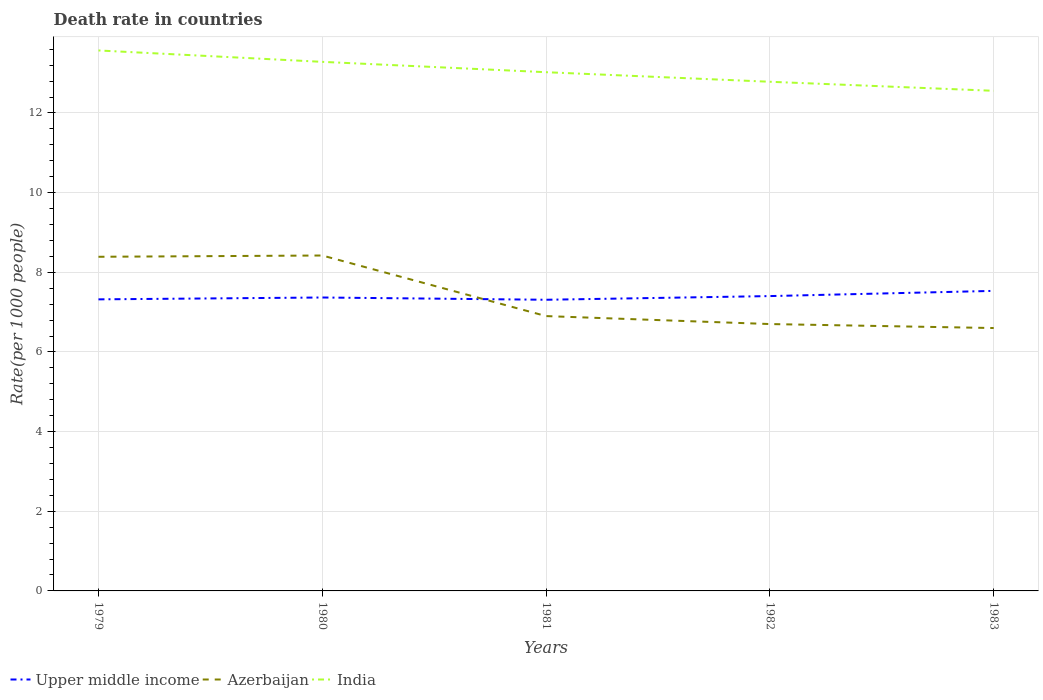Is the number of lines equal to the number of legend labels?
Provide a succinct answer. Yes. Across all years, what is the maximum death rate in Upper middle income?
Keep it short and to the point. 7.31. In which year was the death rate in Upper middle income maximum?
Give a very brief answer. 1981. What is the total death rate in Azerbaijan in the graph?
Your answer should be compact. 1.52. What is the difference between the highest and the second highest death rate in Azerbaijan?
Keep it short and to the point. 1.82. What is the difference between the highest and the lowest death rate in India?
Make the answer very short. 2. Are the values on the major ticks of Y-axis written in scientific E-notation?
Provide a succinct answer. No. Does the graph contain any zero values?
Keep it short and to the point. No. Where does the legend appear in the graph?
Provide a short and direct response. Bottom left. What is the title of the graph?
Your answer should be compact. Death rate in countries. What is the label or title of the Y-axis?
Your response must be concise. Rate(per 1000 people). What is the Rate(per 1000 people) of Upper middle income in 1979?
Offer a terse response. 7.32. What is the Rate(per 1000 people) of Azerbaijan in 1979?
Give a very brief answer. 8.39. What is the Rate(per 1000 people) of India in 1979?
Your answer should be compact. 13.57. What is the Rate(per 1000 people) of Upper middle income in 1980?
Provide a succinct answer. 7.37. What is the Rate(per 1000 people) in Azerbaijan in 1980?
Ensure brevity in your answer.  8.42. What is the Rate(per 1000 people) of India in 1980?
Ensure brevity in your answer.  13.28. What is the Rate(per 1000 people) of Upper middle income in 1981?
Provide a short and direct response. 7.31. What is the Rate(per 1000 people) of India in 1981?
Make the answer very short. 13.02. What is the Rate(per 1000 people) in Upper middle income in 1982?
Provide a short and direct response. 7.4. What is the Rate(per 1000 people) of India in 1982?
Ensure brevity in your answer.  12.78. What is the Rate(per 1000 people) in Upper middle income in 1983?
Your answer should be compact. 7.53. What is the Rate(per 1000 people) in India in 1983?
Provide a short and direct response. 12.56. Across all years, what is the maximum Rate(per 1000 people) of Upper middle income?
Provide a succinct answer. 7.53. Across all years, what is the maximum Rate(per 1000 people) of Azerbaijan?
Provide a short and direct response. 8.42. Across all years, what is the maximum Rate(per 1000 people) of India?
Your answer should be compact. 13.57. Across all years, what is the minimum Rate(per 1000 people) in Upper middle income?
Give a very brief answer. 7.31. Across all years, what is the minimum Rate(per 1000 people) in Azerbaijan?
Your answer should be very brief. 6.6. Across all years, what is the minimum Rate(per 1000 people) of India?
Give a very brief answer. 12.56. What is the total Rate(per 1000 people) in Upper middle income in the graph?
Your response must be concise. 36.93. What is the total Rate(per 1000 people) of Azerbaijan in the graph?
Keep it short and to the point. 37.01. What is the total Rate(per 1000 people) in India in the graph?
Your response must be concise. 65.21. What is the difference between the Rate(per 1000 people) in Upper middle income in 1979 and that in 1980?
Your answer should be very brief. -0.05. What is the difference between the Rate(per 1000 people) of Azerbaijan in 1979 and that in 1980?
Your response must be concise. -0.03. What is the difference between the Rate(per 1000 people) of India in 1979 and that in 1980?
Provide a short and direct response. 0.29. What is the difference between the Rate(per 1000 people) in Upper middle income in 1979 and that in 1981?
Ensure brevity in your answer.  0.01. What is the difference between the Rate(per 1000 people) in Azerbaijan in 1979 and that in 1981?
Give a very brief answer. 1.49. What is the difference between the Rate(per 1000 people) of India in 1979 and that in 1981?
Your answer should be very brief. 0.55. What is the difference between the Rate(per 1000 people) of Upper middle income in 1979 and that in 1982?
Your response must be concise. -0.08. What is the difference between the Rate(per 1000 people) of Azerbaijan in 1979 and that in 1982?
Provide a succinct answer. 1.69. What is the difference between the Rate(per 1000 people) in India in 1979 and that in 1982?
Keep it short and to the point. 0.79. What is the difference between the Rate(per 1000 people) in Upper middle income in 1979 and that in 1983?
Make the answer very short. -0.21. What is the difference between the Rate(per 1000 people) in Azerbaijan in 1979 and that in 1983?
Offer a terse response. 1.79. What is the difference between the Rate(per 1000 people) in Upper middle income in 1980 and that in 1981?
Keep it short and to the point. 0.06. What is the difference between the Rate(per 1000 people) in Azerbaijan in 1980 and that in 1981?
Provide a short and direct response. 1.52. What is the difference between the Rate(per 1000 people) of India in 1980 and that in 1981?
Offer a terse response. 0.26. What is the difference between the Rate(per 1000 people) of Upper middle income in 1980 and that in 1982?
Offer a terse response. -0.04. What is the difference between the Rate(per 1000 people) in Azerbaijan in 1980 and that in 1982?
Your answer should be compact. 1.72. What is the difference between the Rate(per 1000 people) in Upper middle income in 1980 and that in 1983?
Offer a terse response. -0.17. What is the difference between the Rate(per 1000 people) of Azerbaijan in 1980 and that in 1983?
Provide a short and direct response. 1.82. What is the difference between the Rate(per 1000 people) in India in 1980 and that in 1983?
Offer a very short reply. 0.73. What is the difference between the Rate(per 1000 people) of Upper middle income in 1981 and that in 1982?
Make the answer very short. -0.09. What is the difference between the Rate(per 1000 people) in India in 1981 and that in 1982?
Provide a short and direct response. 0.24. What is the difference between the Rate(per 1000 people) in Upper middle income in 1981 and that in 1983?
Make the answer very short. -0.22. What is the difference between the Rate(per 1000 people) of India in 1981 and that in 1983?
Your answer should be compact. 0.47. What is the difference between the Rate(per 1000 people) of Upper middle income in 1982 and that in 1983?
Ensure brevity in your answer.  -0.13. What is the difference between the Rate(per 1000 people) of Azerbaijan in 1982 and that in 1983?
Offer a terse response. 0.1. What is the difference between the Rate(per 1000 people) of India in 1982 and that in 1983?
Make the answer very short. 0.23. What is the difference between the Rate(per 1000 people) of Upper middle income in 1979 and the Rate(per 1000 people) of Azerbaijan in 1980?
Offer a very short reply. -1.1. What is the difference between the Rate(per 1000 people) in Upper middle income in 1979 and the Rate(per 1000 people) in India in 1980?
Offer a terse response. -5.96. What is the difference between the Rate(per 1000 people) of Azerbaijan in 1979 and the Rate(per 1000 people) of India in 1980?
Offer a very short reply. -4.89. What is the difference between the Rate(per 1000 people) in Upper middle income in 1979 and the Rate(per 1000 people) in Azerbaijan in 1981?
Provide a short and direct response. 0.42. What is the difference between the Rate(per 1000 people) of Upper middle income in 1979 and the Rate(per 1000 people) of India in 1981?
Keep it short and to the point. -5.7. What is the difference between the Rate(per 1000 people) in Azerbaijan in 1979 and the Rate(per 1000 people) in India in 1981?
Ensure brevity in your answer.  -4.63. What is the difference between the Rate(per 1000 people) in Upper middle income in 1979 and the Rate(per 1000 people) in Azerbaijan in 1982?
Make the answer very short. 0.62. What is the difference between the Rate(per 1000 people) in Upper middle income in 1979 and the Rate(per 1000 people) in India in 1982?
Your answer should be compact. -5.46. What is the difference between the Rate(per 1000 people) of Azerbaijan in 1979 and the Rate(per 1000 people) of India in 1982?
Give a very brief answer. -4.39. What is the difference between the Rate(per 1000 people) in Upper middle income in 1979 and the Rate(per 1000 people) in Azerbaijan in 1983?
Offer a very short reply. 0.72. What is the difference between the Rate(per 1000 people) in Upper middle income in 1979 and the Rate(per 1000 people) in India in 1983?
Provide a short and direct response. -5.24. What is the difference between the Rate(per 1000 people) in Azerbaijan in 1979 and the Rate(per 1000 people) in India in 1983?
Your answer should be very brief. -4.17. What is the difference between the Rate(per 1000 people) of Upper middle income in 1980 and the Rate(per 1000 people) of Azerbaijan in 1981?
Offer a terse response. 0.47. What is the difference between the Rate(per 1000 people) in Upper middle income in 1980 and the Rate(per 1000 people) in India in 1981?
Your response must be concise. -5.66. What is the difference between the Rate(per 1000 people) in Azerbaijan in 1980 and the Rate(per 1000 people) in India in 1981?
Offer a very short reply. -4.6. What is the difference between the Rate(per 1000 people) in Upper middle income in 1980 and the Rate(per 1000 people) in Azerbaijan in 1982?
Your answer should be very brief. 0.67. What is the difference between the Rate(per 1000 people) of Upper middle income in 1980 and the Rate(per 1000 people) of India in 1982?
Provide a succinct answer. -5.42. What is the difference between the Rate(per 1000 people) of Azerbaijan in 1980 and the Rate(per 1000 people) of India in 1982?
Provide a succinct answer. -4.36. What is the difference between the Rate(per 1000 people) in Upper middle income in 1980 and the Rate(per 1000 people) in Azerbaijan in 1983?
Your response must be concise. 0.77. What is the difference between the Rate(per 1000 people) in Upper middle income in 1980 and the Rate(per 1000 people) in India in 1983?
Ensure brevity in your answer.  -5.19. What is the difference between the Rate(per 1000 people) in Azerbaijan in 1980 and the Rate(per 1000 people) in India in 1983?
Give a very brief answer. -4.13. What is the difference between the Rate(per 1000 people) in Upper middle income in 1981 and the Rate(per 1000 people) in Azerbaijan in 1982?
Give a very brief answer. 0.61. What is the difference between the Rate(per 1000 people) in Upper middle income in 1981 and the Rate(per 1000 people) in India in 1982?
Give a very brief answer. -5.47. What is the difference between the Rate(per 1000 people) in Azerbaijan in 1981 and the Rate(per 1000 people) in India in 1982?
Your answer should be compact. -5.88. What is the difference between the Rate(per 1000 people) in Upper middle income in 1981 and the Rate(per 1000 people) in Azerbaijan in 1983?
Your answer should be very brief. 0.71. What is the difference between the Rate(per 1000 people) of Upper middle income in 1981 and the Rate(per 1000 people) of India in 1983?
Offer a very short reply. -5.25. What is the difference between the Rate(per 1000 people) in Azerbaijan in 1981 and the Rate(per 1000 people) in India in 1983?
Keep it short and to the point. -5.66. What is the difference between the Rate(per 1000 people) of Upper middle income in 1982 and the Rate(per 1000 people) of Azerbaijan in 1983?
Give a very brief answer. 0.8. What is the difference between the Rate(per 1000 people) in Upper middle income in 1982 and the Rate(per 1000 people) in India in 1983?
Offer a terse response. -5.15. What is the difference between the Rate(per 1000 people) of Azerbaijan in 1982 and the Rate(per 1000 people) of India in 1983?
Ensure brevity in your answer.  -5.86. What is the average Rate(per 1000 people) in Upper middle income per year?
Ensure brevity in your answer.  7.39. What is the average Rate(per 1000 people) of Azerbaijan per year?
Keep it short and to the point. 7.4. What is the average Rate(per 1000 people) of India per year?
Your answer should be compact. 13.04. In the year 1979, what is the difference between the Rate(per 1000 people) in Upper middle income and Rate(per 1000 people) in Azerbaijan?
Your answer should be very brief. -1.07. In the year 1979, what is the difference between the Rate(per 1000 people) in Upper middle income and Rate(per 1000 people) in India?
Your answer should be very brief. -6.25. In the year 1979, what is the difference between the Rate(per 1000 people) of Azerbaijan and Rate(per 1000 people) of India?
Offer a terse response. -5.18. In the year 1980, what is the difference between the Rate(per 1000 people) of Upper middle income and Rate(per 1000 people) of Azerbaijan?
Your answer should be very brief. -1.05. In the year 1980, what is the difference between the Rate(per 1000 people) in Upper middle income and Rate(per 1000 people) in India?
Your answer should be very brief. -5.92. In the year 1980, what is the difference between the Rate(per 1000 people) of Azerbaijan and Rate(per 1000 people) of India?
Your answer should be compact. -4.86. In the year 1981, what is the difference between the Rate(per 1000 people) of Upper middle income and Rate(per 1000 people) of Azerbaijan?
Provide a succinct answer. 0.41. In the year 1981, what is the difference between the Rate(per 1000 people) in Upper middle income and Rate(per 1000 people) in India?
Ensure brevity in your answer.  -5.71. In the year 1981, what is the difference between the Rate(per 1000 people) in Azerbaijan and Rate(per 1000 people) in India?
Your answer should be compact. -6.12. In the year 1982, what is the difference between the Rate(per 1000 people) in Upper middle income and Rate(per 1000 people) in Azerbaijan?
Provide a short and direct response. 0.7. In the year 1982, what is the difference between the Rate(per 1000 people) in Upper middle income and Rate(per 1000 people) in India?
Your answer should be compact. -5.38. In the year 1982, what is the difference between the Rate(per 1000 people) of Azerbaijan and Rate(per 1000 people) of India?
Make the answer very short. -6.08. In the year 1983, what is the difference between the Rate(per 1000 people) in Upper middle income and Rate(per 1000 people) in Azerbaijan?
Provide a short and direct response. 0.93. In the year 1983, what is the difference between the Rate(per 1000 people) in Upper middle income and Rate(per 1000 people) in India?
Ensure brevity in your answer.  -5.02. In the year 1983, what is the difference between the Rate(per 1000 people) of Azerbaijan and Rate(per 1000 people) of India?
Your response must be concise. -5.96. What is the ratio of the Rate(per 1000 people) in Upper middle income in 1979 to that in 1980?
Offer a very short reply. 0.99. What is the ratio of the Rate(per 1000 people) in India in 1979 to that in 1980?
Offer a very short reply. 1.02. What is the ratio of the Rate(per 1000 people) of Azerbaijan in 1979 to that in 1981?
Ensure brevity in your answer.  1.22. What is the ratio of the Rate(per 1000 people) in India in 1979 to that in 1981?
Keep it short and to the point. 1.04. What is the ratio of the Rate(per 1000 people) of Upper middle income in 1979 to that in 1982?
Give a very brief answer. 0.99. What is the ratio of the Rate(per 1000 people) in Azerbaijan in 1979 to that in 1982?
Your answer should be compact. 1.25. What is the ratio of the Rate(per 1000 people) in India in 1979 to that in 1982?
Provide a short and direct response. 1.06. What is the ratio of the Rate(per 1000 people) in Upper middle income in 1979 to that in 1983?
Offer a terse response. 0.97. What is the ratio of the Rate(per 1000 people) of Azerbaijan in 1979 to that in 1983?
Provide a short and direct response. 1.27. What is the ratio of the Rate(per 1000 people) of India in 1979 to that in 1983?
Offer a terse response. 1.08. What is the ratio of the Rate(per 1000 people) in Azerbaijan in 1980 to that in 1981?
Ensure brevity in your answer.  1.22. What is the ratio of the Rate(per 1000 people) in India in 1980 to that in 1981?
Offer a very short reply. 1.02. What is the ratio of the Rate(per 1000 people) of Upper middle income in 1980 to that in 1982?
Offer a terse response. 1. What is the ratio of the Rate(per 1000 people) of Azerbaijan in 1980 to that in 1982?
Your answer should be compact. 1.26. What is the ratio of the Rate(per 1000 people) in India in 1980 to that in 1982?
Your answer should be compact. 1.04. What is the ratio of the Rate(per 1000 people) of Upper middle income in 1980 to that in 1983?
Provide a short and direct response. 0.98. What is the ratio of the Rate(per 1000 people) of Azerbaijan in 1980 to that in 1983?
Ensure brevity in your answer.  1.28. What is the ratio of the Rate(per 1000 people) in India in 1980 to that in 1983?
Keep it short and to the point. 1.06. What is the ratio of the Rate(per 1000 people) of Upper middle income in 1981 to that in 1982?
Your response must be concise. 0.99. What is the ratio of the Rate(per 1000 people) in Azerbaijan in 1981 to that in 1982?
Keep it short and to the point. 1.03. What is the ratio of the Rate(per 1000 people) in India in 1981 to that in 1982?
Provide a succinct answer. 1.02. What is the ratio of the Rate(per 1000 people) in Upper middle income in 1981 to that in 1983?
Offer a very short reply. 0.97. What is the ratio of the Rate(per 1000 people) in Azerbaijan in 1981 to that in 1983?
Give a very brief answer. 1.05. What is the ratio of the Rate(per 1000 people) in India in 1981 to that in 1983?
Make the answer very short. 1.04. What is the ratio of the Rate(per 1000 people) of Upper middle income in 1982 to that in 1983?
Provide a short and direct response. 0.98. What is the ratio of the Rate(per 1000 people) in Azerbaijan in 1982 to that in 1983?
Give a very brief answer. 1.02. What is the ratio of the Rate(per 1000 people) of India in 1982 to that in 1983?
Provide a succinct answer. 1.02. What is the difference between the highest and the second highest Rate(per 1000 people) in Upper middle income?
Keep it short and to the point. 0.13. What is the difference between the highest and the second highest Rate(per 1000 people) of Azerbaijan?
Provide a succinct answer. 0.03. What is the difference between the highest and the second highest Rate(per 1000 people) in India?
Offer a terse response. 0.29. What is the difference between the highest and the lowest Rate(per 1000 people) in Upper middle income?
Offer a terse response. 0.22. What is the difference between the highest and the lowest Rate(per 1000 people) in Azerbaijan?
Your answer should be compact. 1.82. 